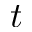Convert formula to latex. <formula><loc_0><loc_0><loc_500><loc_500>t</formula> 